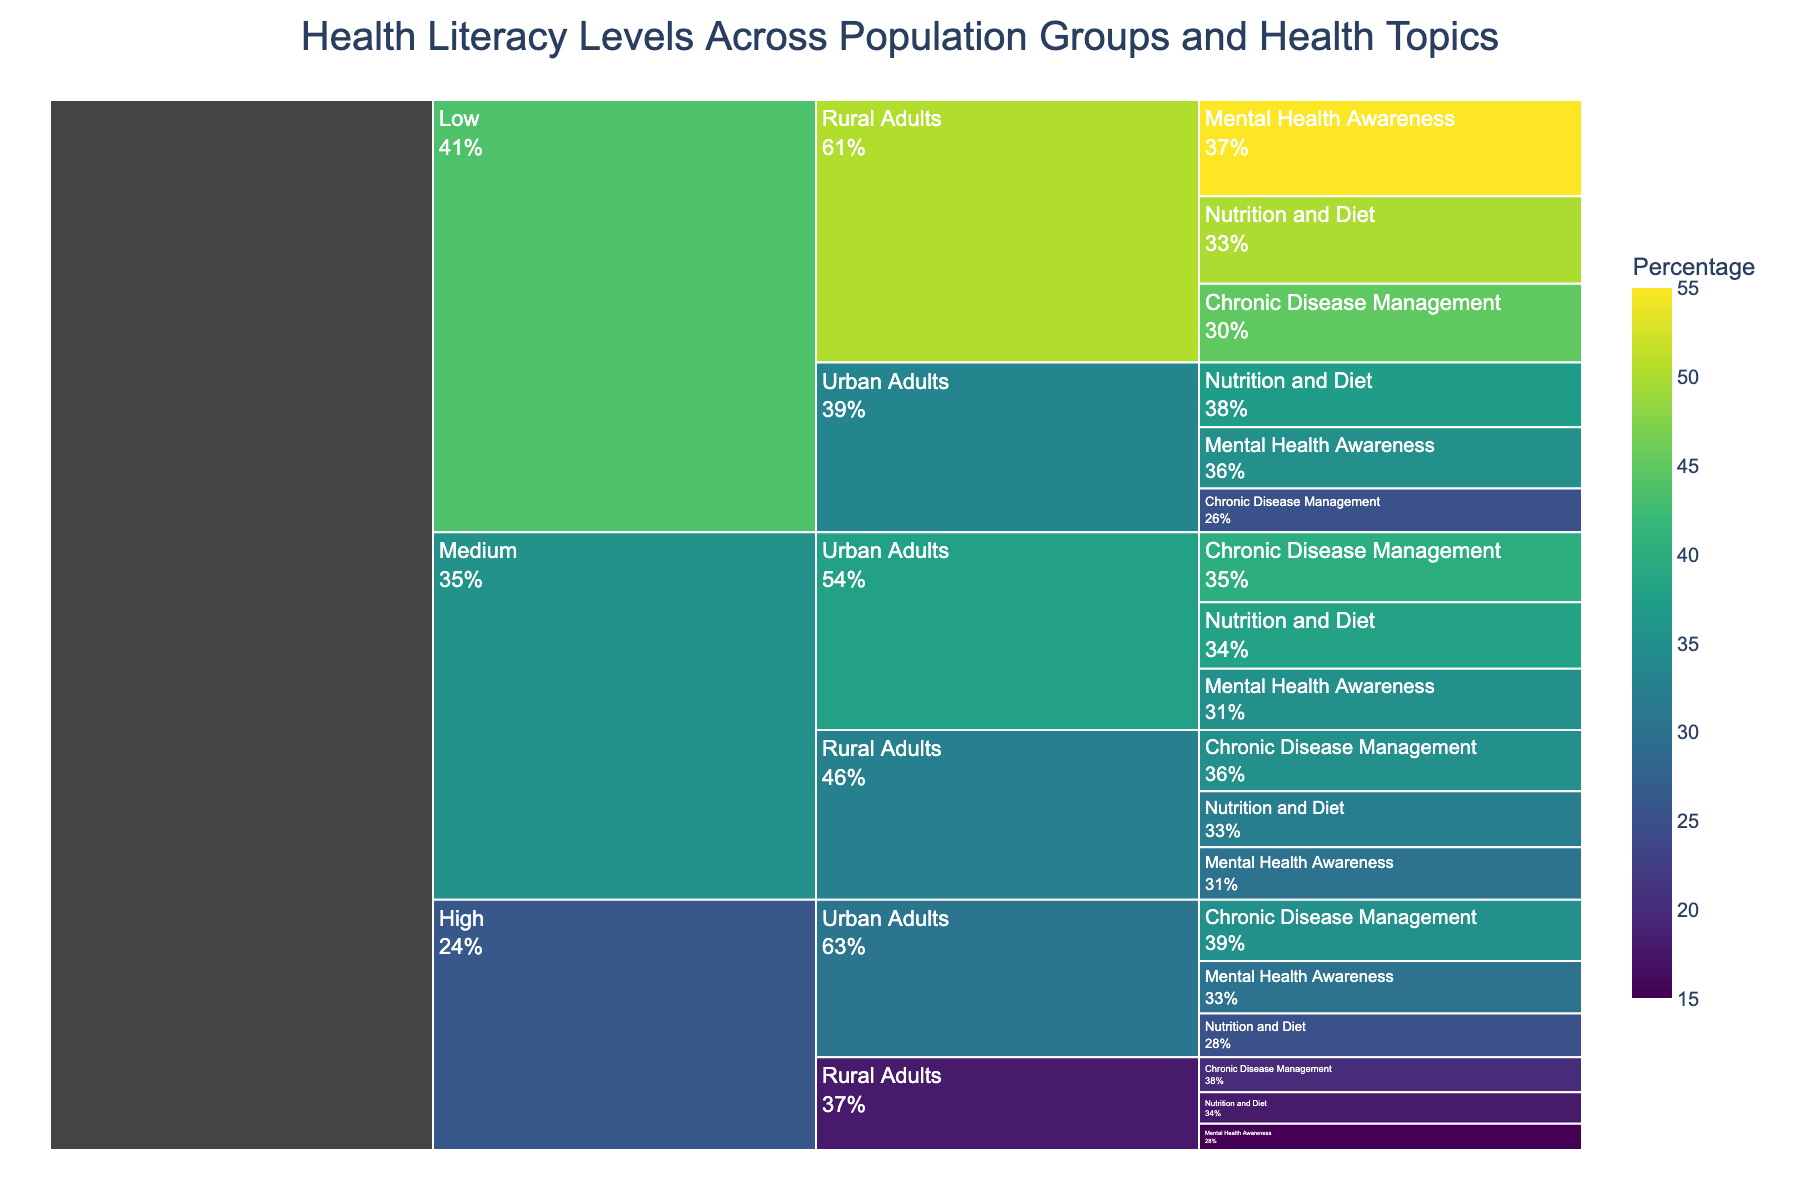How many specific health topics are highlighted for "High" health literacy levels for urban adults? The chart shows the specific health topics for each health literacy level and population group. There are three specific topics under "High" health literacy levels for urban adults: Chronic Disease Management, Mental Health Awareness, and Nutrition and Diet.
Answer: 3 Which population group has the lowest percentage for "High" nutrition and diet literacy? Looking at the "High" health literacy category, the percentages for "Nutrition and Diet" are 25% for Urban Adults and 18% for Rural Adults. The lowest percentage is for Rural Adults.
Answer: Rural Adults What percentage of rural adults has medium health literacy in chronic disease management? The icicle chart shows the percentage next to "Medium" health literacy for Chronic Disease Management under Rural Adults, which is 35%.
Answer: 35% Compare the percentage of low health literacy levels in mental health awareness between urban and rural adults. The percentages for "Low" health literacy in Mental Health Awareness are 35% for Urban Adults and 55% for Rural Adults. Rural Adults have a higher percentage compared to Urban Adults.
Answer: Rural Adults have a higher percentage What is the total percentage of urban adults under medium health literacy levels across all specific health topics? The chart depicts the percentages for each health topic under "Medium" health literacy for Urban Adults: Chronic Disease Management (40%), Mental Health Awareness (35%), and Nutrition and Diet (38%). Adding them gives 40% + 35% + 38% = 113%.
Answer: 113% Which specific health topic has the highest percentage of low health literacy in rural adults? By examining the "Low" health literacy category for Rural Adults in the chart, Mental Health Awareness has the highest percentage at 55%.
Answer: Mental Health Awareness Between chronic disease management and nutrition and diet, which topic has a higher percentage of medium health literacy in rural adults? Evaluating the "Medium" health literacy category for Rural Adults, Chronic Disease Management has 35%, and Nutrition and Diet has 32%. Chronic Disease Management has a higher percentage.
Answer: Chronic Disease Management How many details (specific health topics and population groups) are depicted under "Medium" health literacy levels? The chart segments "Medium" health literacy into two population groups, Urban Adults and Rural Adults, each with three specific health topics. Thus, we see 2 groups * 3 topics = 6 details.
Answer: 6 What is the average percentage for high health literacy regarding mental health awareness in all population groups? The chart shows two values for high health literacy in Mental Health Awareness: Urban Adults at 30% and Rural Adults at 15%. The average is calculated as (30% + 15%) / 2 = 22.5%.
Answer: 22.5% Among the three health literacy levels, which one has the highest percentage for nutrition and diet in urban adults? Comparing the chart values for Urban Adults in Nutrition and Diet: High (25%), Medium (38%), and Low (37%). Medium has the highest percentage.
Answer: Medium 